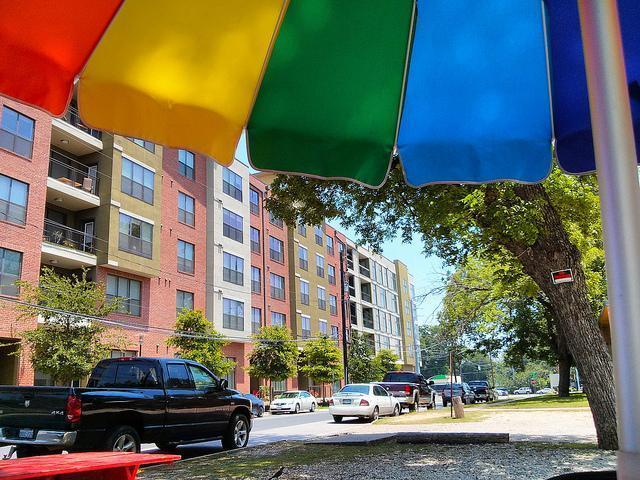How many sandwich on the plate?
Give a very brief answer. 0. 